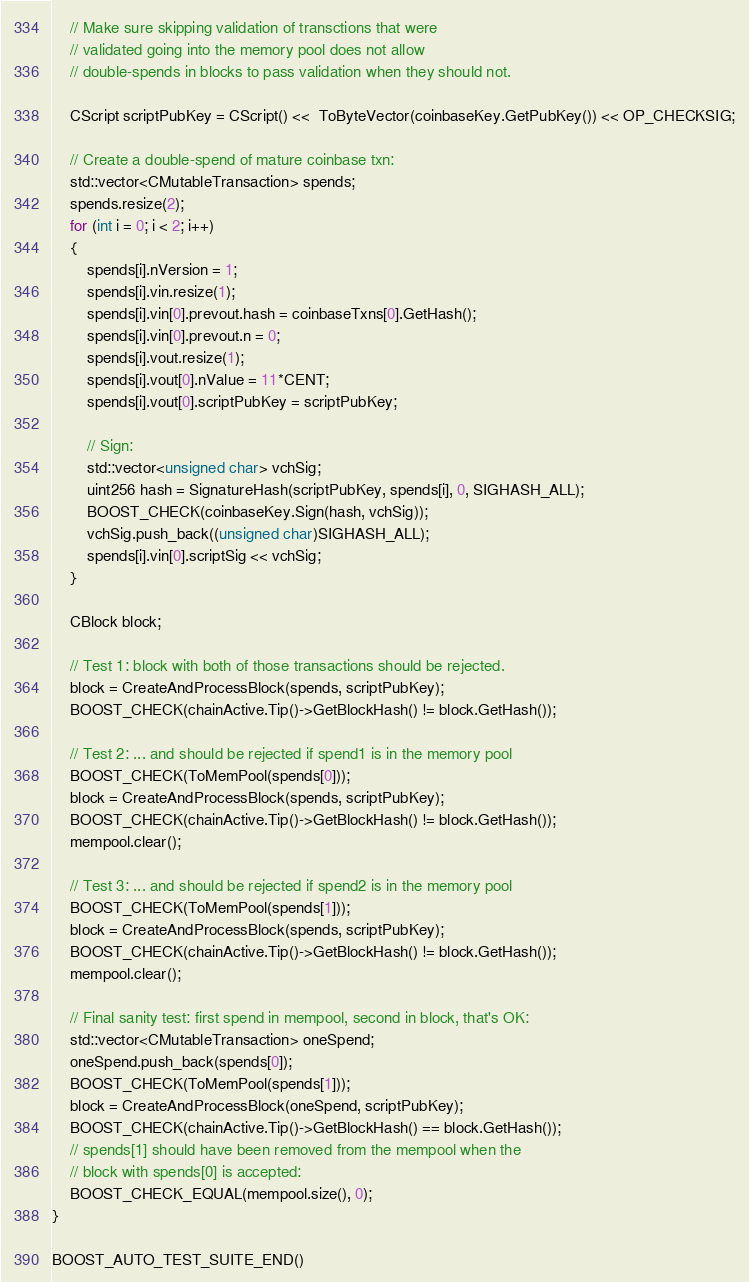<code> <loc_0><loc_0><loc_500><loc_500><_C++_>    // Make sure skipping validation of transctions that were
    // validated going into the memory pool does not allow
    // double-spends in blocks to pass validation when they should not.

    CScript scriptPubKey = CScript() <<  ToByteVector(coinbaseKey.GetPubKey()) << OP_CHECKSIG;

    // Create a double-spend of mature coinbase txn:
    std::vector<CMutableTransaction> spends;
    spends.resize(2);
    for (int i = 0; i < 2; i++)
    {
        spends[i].nVersion = 1;
        spends[i].vin.resize(1);
        spends[i].vin[0].prevout.hash = coinbaseTxns[0].GetHash();
        spends[i].vin[0].prevout.n = 0;
        spends[i].vout.resize(1);
        spends[i].vout[0].nValue = 11*CENT;
        spends[i].vout[0].scriptPubKey = scriptPubKey;

        // Sign:
        std::vector<unsigned char> vchSig;
        uint256 hash = SignatureHash(scriptPubKey, spends[i], 0, SIGHASH_ALL);
        BOOST_CHECK(coinbaseKey.Sign(hash, vchSig));
        vchSig.push_back((unsigned char)SIGHASH_ALL);
        spends[i].vin[0].scriptSig << vchSig;
    }

    CBlock block;

    // Test 1: block with both of those transactions should be rejected.
    block = CreateAndProcessBlock(spends, scriptPubKey);
    BOOST_CHECK(chainActive.Tip()->GetBlockHash() != block.GetHash());

    // Test 2: ... and should be rejected if spend1 is in the memory pool
    BOOST_CHECK(ToMemPool(spends[0]));
    block = CreateAndProcessBlock(spends, scriptPubKey);
    BOOST_CHECK(chainActive.Tip()->GetBlockHash() != block.GetHash());
    mempool.clear();

    // Test 3: ... and should be rejected if spend2 is in the memory pool
    BOOST_CHECK(ToMemPool(spends[1]));
    block = CreateAndProcessBlock(spends, scriptPubKey);
    BOOST_CHECK(chainActive.Tip()->GetBlockHash() != block.GetHash());
    mempool.clear();

    // Final sanity test: first spend in mempool, second in block, that's OK:
    std::vector<CMutableTransaction> oneSpend;
    oneSpend.push_back(spends[0]);
    BOOST_CHECK(ToMemPool(spends[1]));
    block = CreateAndProcessBlock(oneSpend, scriptPubKey);
    BOOST_CHECK(chainActive.Tip()->GetBlockHash() == block.GetHash());
    // spends[1] should have been removed from the mempool when the
    // block with spends[0] is accepted:
    BOOST_CHECK_EQUAL(mempool.size(), 0);
}

BOOST_AUTO_TEST_SUITE_END()
</code> 